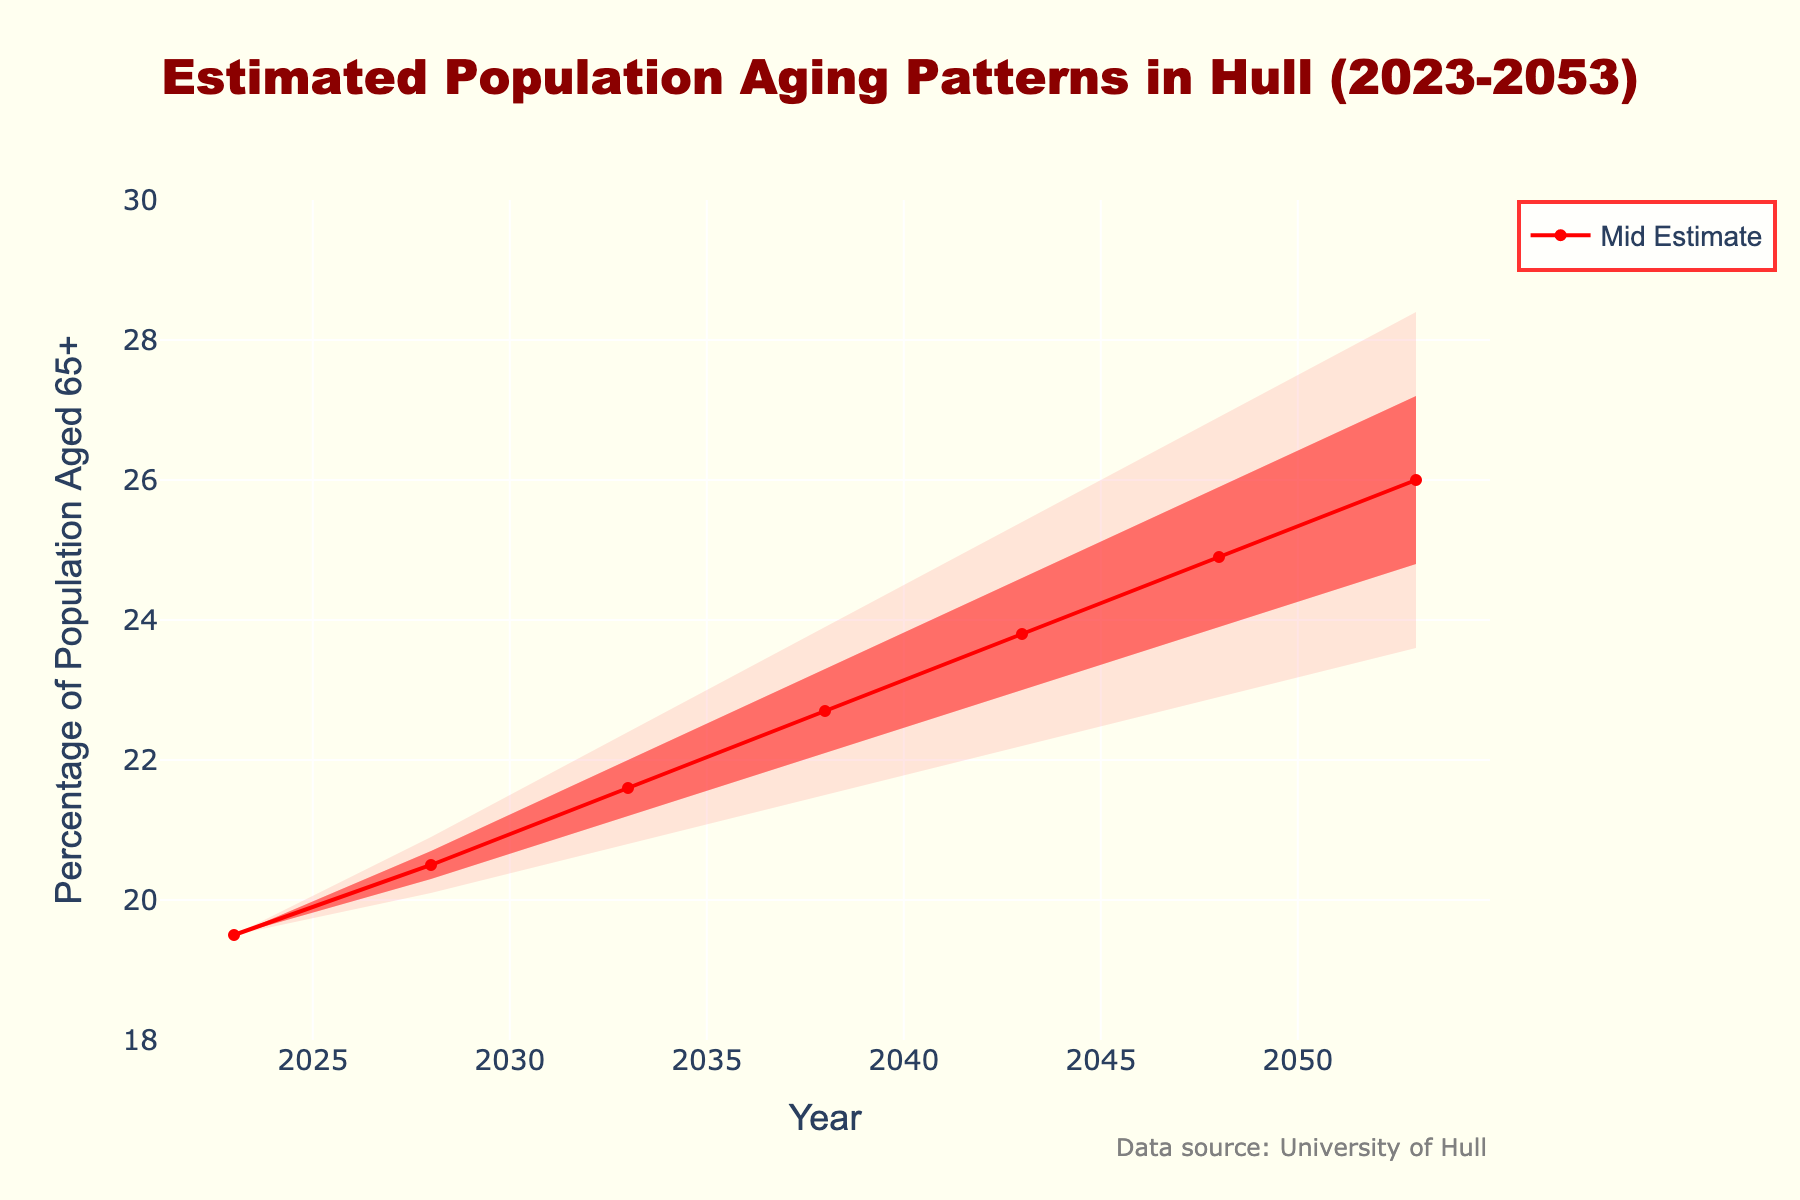What's the title of the chart? The title is located at the top of the chart and reads "Estimated Population Aging Patterns in Hull (2023-2053)"
Answer: Estimated Population Aging Patterns in Hull (2023-2053) What variable is represented on the y-axis? The y-axis label indicates it represents "Percentage of Population Aged 65+"
Answer: Percentage of Population Aged 65+ Which estimate scenario has the highest value in 2053? By looking at the endpoints in 2053, the 'High Estimate' scenario reaches the highest value.
Answer: High Estimate How does the 'Mid Estimate' value change from 2023 to 2043? Review the 'Mid Estimate' values in 2023 and 2043 and notice how they change from 19.5 to 23.8. The change is 23.8 - 19.5 = 4.3.
Answer: 4.3 Which year do all estimates start to diverge? The estimates start diverging in 2028, as seen by the spread between the different scenarios after this year.
Answer: 2028 What is the color of the fill for the area between the 'Low-Mid Estimate' and the 'High Estimate'? The color of this fill is 'rgba(255,0,0,0.2)', which corresponds to a shade of red with medium transparency.
Answer: A medium transparent red What is the difference between 'Low Estimate' and 'High Estimate' in 2048? From the values at 2048, subtract the 'Low Estimate' of 22.9 from the 'High Estimate' of 26.9, which gives us 26.9 - 22.9 = 4.0.
Answer: 4.0 What is the trend seen in the 'Mid Estimate' line from 2023 to 2053? Observe the 'Mid Estimate' line, which shows an increasing trend throughout the period from 19.5 in 2023 to 26.0 in 2053.
Answer: Increasing trend In 2033, which estimate interval shows the greatest range? The greatest range in 2033 is found between the 'Low Estimate' of 20.8 and the 'High Estimate' of 22.4, giving a range of 1.6. This spread is bigger compared to other years around it.
Answer: 1.6 (between Low and High Estimate) How does the 'High Estimate' change from 2028 to 2038? Examine the 'High Estimate' values for 2028 and 2038, where the change is from 20.9 to 23.9. Therefore, the change is 23.9 – 20.9 = 3.0.
Answer: 3.0 